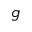Convert formula to latex. <formula><loc_0><loc_0><loc_500><loc_500>g</formula> 